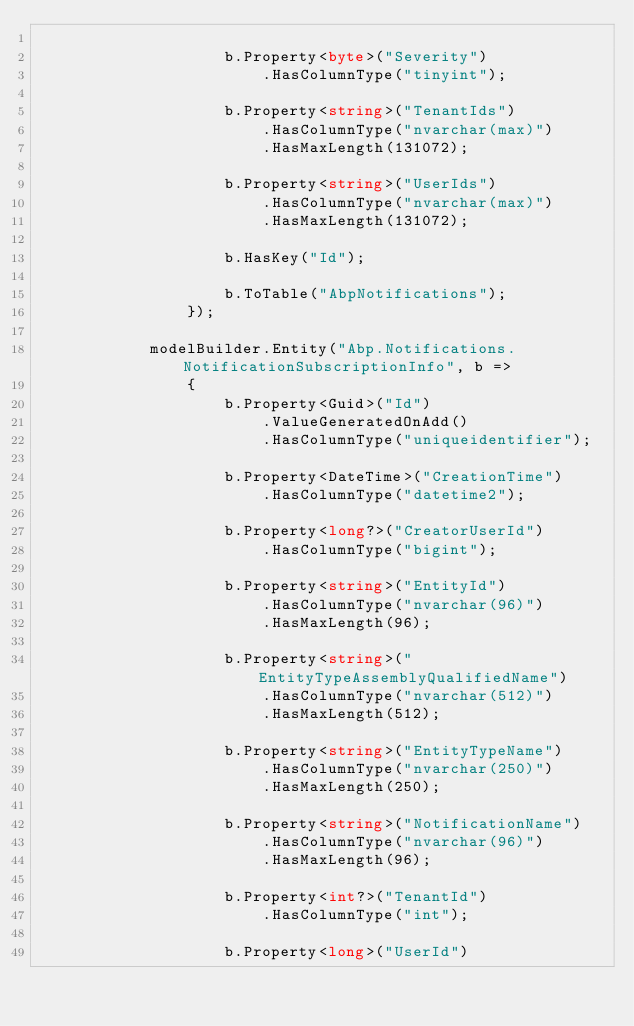Convert code to text. <code><loc_0><loc_0><loc_500><loc_500><_C#_>
                    b.Property<byte>("Severity")
                        .HasColumnType("tinyint");

                    b.Property<string>("TenantIds")
                        .HasColumnType("nvarchar(max)")
                        .HasMaxLength(131072);

                    b.Property<string>("UserIds")
                        .HasColumnType("nvarchar(max)")
                        .HasMaxLength(131072);

                    b.HasKey("Id");

                    b.ToTable("AbpNotifications");
                });

            modelBuilder.Entity("Abp.Notifications.NotificationSubscriptionInfo", b =>
                {
                    b.Property<Guid>("Id")
                        .ValueGeneratedOnAdd()
                        .HasColumnType("uniqueidentifier");

                    b.Property<DateTime>("CreationTime")
                        .HasColumnType("datetime2");

                    b.Property<long?>("CreatorUserId")
                        .HasColumnType("bigint");

                    b.Property<string>("EntityId")
                        .HasColumnType("nvarchar(96)")
                        .HasMaxLength(96);

                    b.Property<string>("EntityTypeAssemblyQualifiedName")
                        .HasColumnType("nvarchar(512)")
                        .HasMaxLength(512);

                    b.Property<string>("EntityTypeName")
                        .HasColumnType("nvarchar(250)")
                        .HasMaxLength(250);

                    b.Property<string>("NotificationName")
                        .HasColumnType("nvarchar(96)")
                        .HasMaxLength(96);

                    b.Property<int?>("TenantId")
                        .HasColumnType("int");

                    b.Property<long>("UserId")</code> 